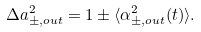Convert formula to latex. <formula><loc_0><loc_0><loc_500><loc_500>\Delta a _ { \pm , o u t } ^ { 2 } = 1 \pm \langle \alpha _ { \pm , o u t } ^ { 2 } ( t ) \rangle .</formula> 